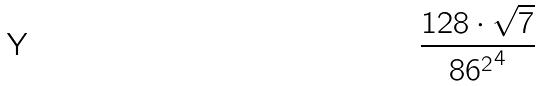<formula> <loc_0><loc_0><loc_500><loc_500>\frac { 1 2 8 \cdot \sqrt { 7 } } { { 8 6 ^ { 2 } } ^ { 4 } }</formula> 